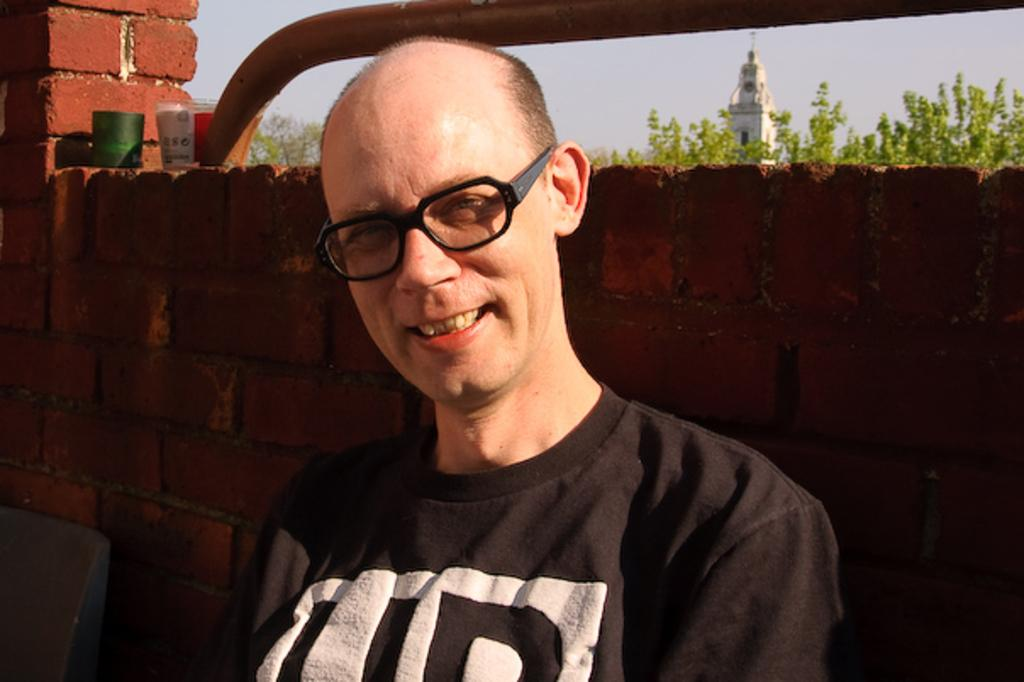What is the person in the image doing? The person is standing near the wall in the image. Can you describe the wall in the image? The wall is made up of red bricks. What can be seen in the background of the image? There are trees and a building visible in the background of the image. What type of pancake is being served on the van in the image? There is no van or pancake present in the image. What shape is the person in the image? The image does not provide enough information to determine the person's shape. 